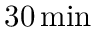Convert formula to latex. <formula><loc_0><loc_0><loc_500><loc_500>3 0 \, { \min }</formula> 